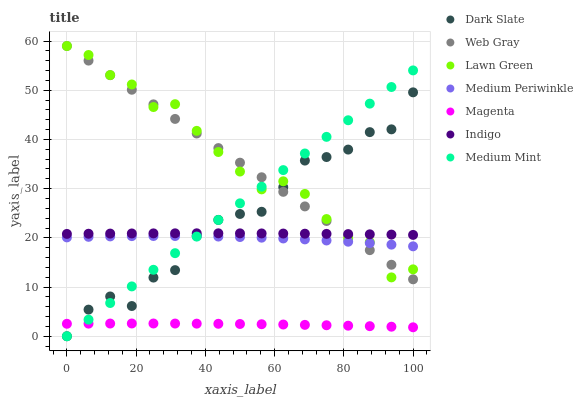Does Magenta have the minimum area under the curve?
Answer yes or no. Yes. Does Lawn Green have the maximum area under the curve?
Answer yes or no. Yes. Does Web Gray have the minimum area under the curve?
Answer yes or no. No. Does Web Gray have the maximum area under the curve?
Answer yes or no. No. Is Medium Mint the smoothest?
Answer yes or no. Yes. Is Dark Slate the roughest?
Answer yes or no. Yes. Is Lawn Green the smoothest?
Answer yes or no. No. Is Lawn Green the roughest?
Answer yes or no. No. Does Medium Mint have the lowest value?
Answer yes or no. Yes. Does Lawn Green have the lowest value?
Answer yes or no. No. Does Web Gray have the highest value?
Answer yes or no. Yes. Does Indigo have the highest value?
Answer yes or no. No. Is Magenta less than Indigo?
Answer yes or no. Yes. Is Medium Periwinkle greater than Magenta?
Answer yes or no. Yes. Does Dark Slate intersect Medium Mint?
Answer yes or no. Yes. Is Dark Slate less than Medium Mint?
Answer yes or no. No. Is Dark Slate greater than Medium Mint?
Answer yes or no. No. Does Magenta intersect Indigo?
Answer yes or no. No. 